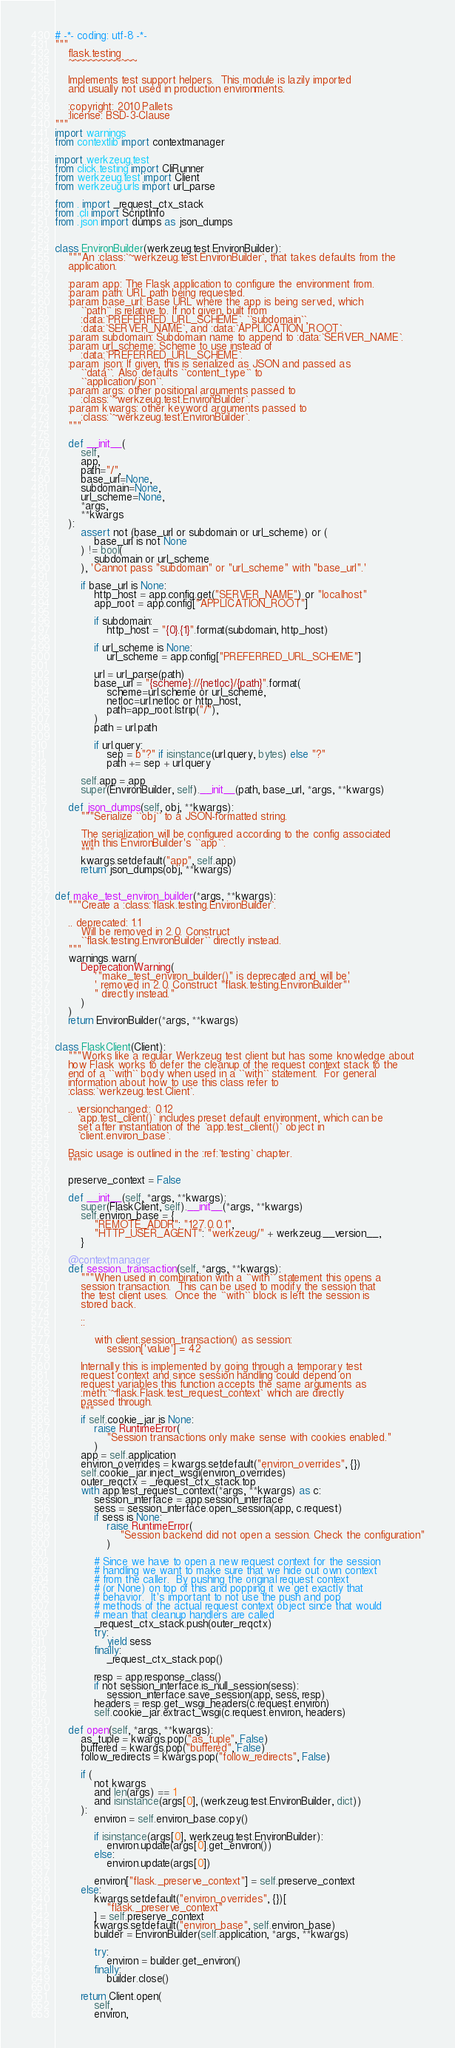<code> <loc_0><loc_0><loc_500><loc_500><_Python_># -*- coding: utf-8 -*-
"""
    flask.testing
    ~~~~~~~~~~~~~

    Implements test support helpers.  This module is lazily imported
    and usually not used in production environments.

    :copyright: 2010 Pallets
    :license: BSD-3-Clause
"""
import warnings
from contextlib import contextmanager

import werkzeug.test
from click.testing import CliRunner
from werkzeug.test import Client
from werkzeug.urls import url_parse

from . import _request_ctx_stack
from .cli import ScriptInfo
from .json import dumps as json_dumps


class EnvironBuilder(werkzeug.test.EnvironBuilder):
    """An :class:`~werkzeug.test.EnvironBuilder`, that takes defaults from the
    application.

    :param app: The Flask application to configure the environment from.
    :param path: URL path being requested.
    :param base_url: Base URL where the app is being served, which
        ``path`` is relative to. If not given, built from
        :data:`PREFERRED_URL_SCHEME`, ``subdomain``,
        :data:`SERVER_NAME`, and :data:`APPLICATION_ROOT`.
    :param subdomain: Subdomain name to append to :data:`SERVER_NAME`.
    :param url_scheme: Scheme to use instead of
        :data:`PREFERRED_URL_SCHEME`.
    :param json: If given, this is serialized as JSON and passed as
        ``data``. Also defaults ``content_type`` to
        ``application/json``.
    :param args: other positional arguments passed to
        :class:`~werkzeug.test.EnvironBuilder`.
    :param kwargs: other keyword arguments passed to
        :class:`~werkzeug.test.EnvironBuilder`.
    """

    def __init__(
        self,
        app,
        path="/",
        base_url=None,
        subdomain=None,
        url_scheme=None,
        *args,
        **kwargs
    ):
        assert not (base_url or subdomain or url_scheme) or (
            base_url is not None
        ) != bool(
            subdomain or url_scheme
        ), 'Cannot pass "subdomain" or "url_scheme" with "base_url".'

        if base_url is None:
            http_host = app.config.get("SERVER_NAME") or "localhost"
            app_root = app.config["APPLICATION_ROOT"]

            if subdomain:
                http_host = "{0}.{1}".format(subdomain, http_host)

            if url_scheme is None:
                url_scheme = app.config["PREFERRED_URL_SCHEME"]

            url = url_parse(path)
            base_url = "{scheme}://{netloc}/{path}".format(
                scheme=url.scheme or url_scheme,
                netloc=url.netloc or http_host,
                path=app_root.lstrip("/"),
            )
            path = url.path

            if url.query:
                sep = b"?" if isinstance(url.query, bytes) else "?"
                path += sep + url.query

        self.app = app
        super(EnvironBuilder, self).__init__(path, base_url, *args, **kwargs)

    def json_dumps(self, obj, **kwargs):
        """Serialize ``obj`` to a JSON-formatted string.

        The serialization will be configured according to the config associated
        with this EnvironBuilder's ``app``.
        """
        kwargs.setdefault("app", self.app)
        return json_dumps(obj, **kwargs)


def make_test_environ_builder(*args, **kwargs):
    """Create a :class:`flask.testing.EnvironBuilder`.

    .. deprecated: 1.1
        Will be removed in 2.0. Construct
        ``flask.testing.EnvironBuilder`` directly instead.
    """
    warnings.warn(
        DeprecationWarning(
            '"make_test_environ_builder()" is deprecated and will be'
            ' removed in 2.0. Construct "flask.testing.EnvironBuilder"'
            " directly instead."
        )
    )
    return EnvironBuilder(*args, **kwargs)


class FlaskClient(Client):
    """Works like a regular Werkzeug test client but has some knowledge about
    how Flask works to defer the cleanup of the request context stack to the
    end of a ``with`` body when used in a ``with`` statement.  For general
    information about how to use this class refer to
    :class:`werkzeug.test.Client`.

    .. versionchanged:: 0.12
       `app.test_client()` includes preset default environment, which can be
       set after instantiation of the `app.test_client()` object in
       `client.environ_base`.

    Basic usage is outlined in the :ref:`testing` chapter.
    """

    preserve_context = False

    def __init__(self, *args, **kwargs):
        super(FlaskClient, self).__init__(*args, **kwargs)
        self.environ_base = {
            "REMOTE_ADDR": "127.0.0.1",
            "HTTP_USER_AGENT": "werkzeug/" + werkzeug.__version__,
        }

    @contextmanager
    def session_transaction(self, *args, **kwargs):
        """When used in combination with a ``with`` statement this opens a
        session transaction.  This can be used to modify the session that
        the test client uses.  Once the ``with`` block is left the session is
        stored back.

        ::

            with client.session_transaction() as session:
                session['value'] = 42

        Internally this is implemented by going through a temporary test
        request context and since session handling could depend on
        request variables this function accepts the same arguments as
        :meth:`~flask.Flask.test_request_context` which are directly
        passed through.
        """
        if self.cookie_jar is None:
            raise RuntimeError(
                "Session transactions only make sense with cookies enabled."
            )
        app = self.application
        environ_overrides = kwargs.setdefault("environ_overrides", {})
        self.cookie_jar.inject_wsgi(environ_overrides)
        outer_reqctx = _request_ctx_stack.top
        with app.test_request_context(*args, **kwargs) as c:
            session_interface = app.session_interface
            sess = session_interface.open_session(app, c.request)
            if sess is None:
                raise RuntimeError(
                    "Session backend did not open a session. Check the configuration"
                )

            # Since we have to open a new request context for the session
            # handling we want to make sure that we hide out own context
            # from the caller.  By pushing the original request context
            # (or None) on top of this and popping it we get exactly that
            # behavior.  It's important to not use the push and pop
            # methods of the actual request context object since that would
            # mean that cleanup handlers are called
            _request_ctx_stack.push(outer_reqctx)
            try:
                yield sess
            finally:
                _request_ctx_stack.pop()

            resp = app.response_class()
            if not session_interface.is_null_session(sess):
                session_interface.save_session(app, sess, resp)
            headers = resp.get_wsgi_headers(c.request.environ)
            self.cookie_jar.extract_wsgi(c.request.environ, headers)

    def open(self, *args, **kwargs):
        as_tuple = kwargs.pop("as_tuple", False)
        buffered = kwargs.pop("buffered", False)
        follow_redirects = kwargs.pop("follow_redirects", False)

        if (
            not kwargs
            and len(args) == 1
            and isinstance(args[0], (werkzeug.test.EnvironBuilder, dict))
        ):
            environ = self.environ_base.copy()

            if isinstance(args[0], werkzeug.test.EnvironBuilder):
                environ.update(args[0].get_environ())
            else:
                environ.update(args[0])

            environ["flask._preserve_context"] = self.preserve_context
        else:
            kwargs.setdefault("environ_overrides", {})[
                "flask._preserve_context"
            ] = self.preserve_context
            kwargs.setdefault("environ_base", self.environ_base)
            builder = EnvironBuilder(self.application, *args, **kwargs)

            try:
                environ = builder.get_environ()
            finally:
                builder.close()

        return Client.open(
            self,
            environ,</code> 